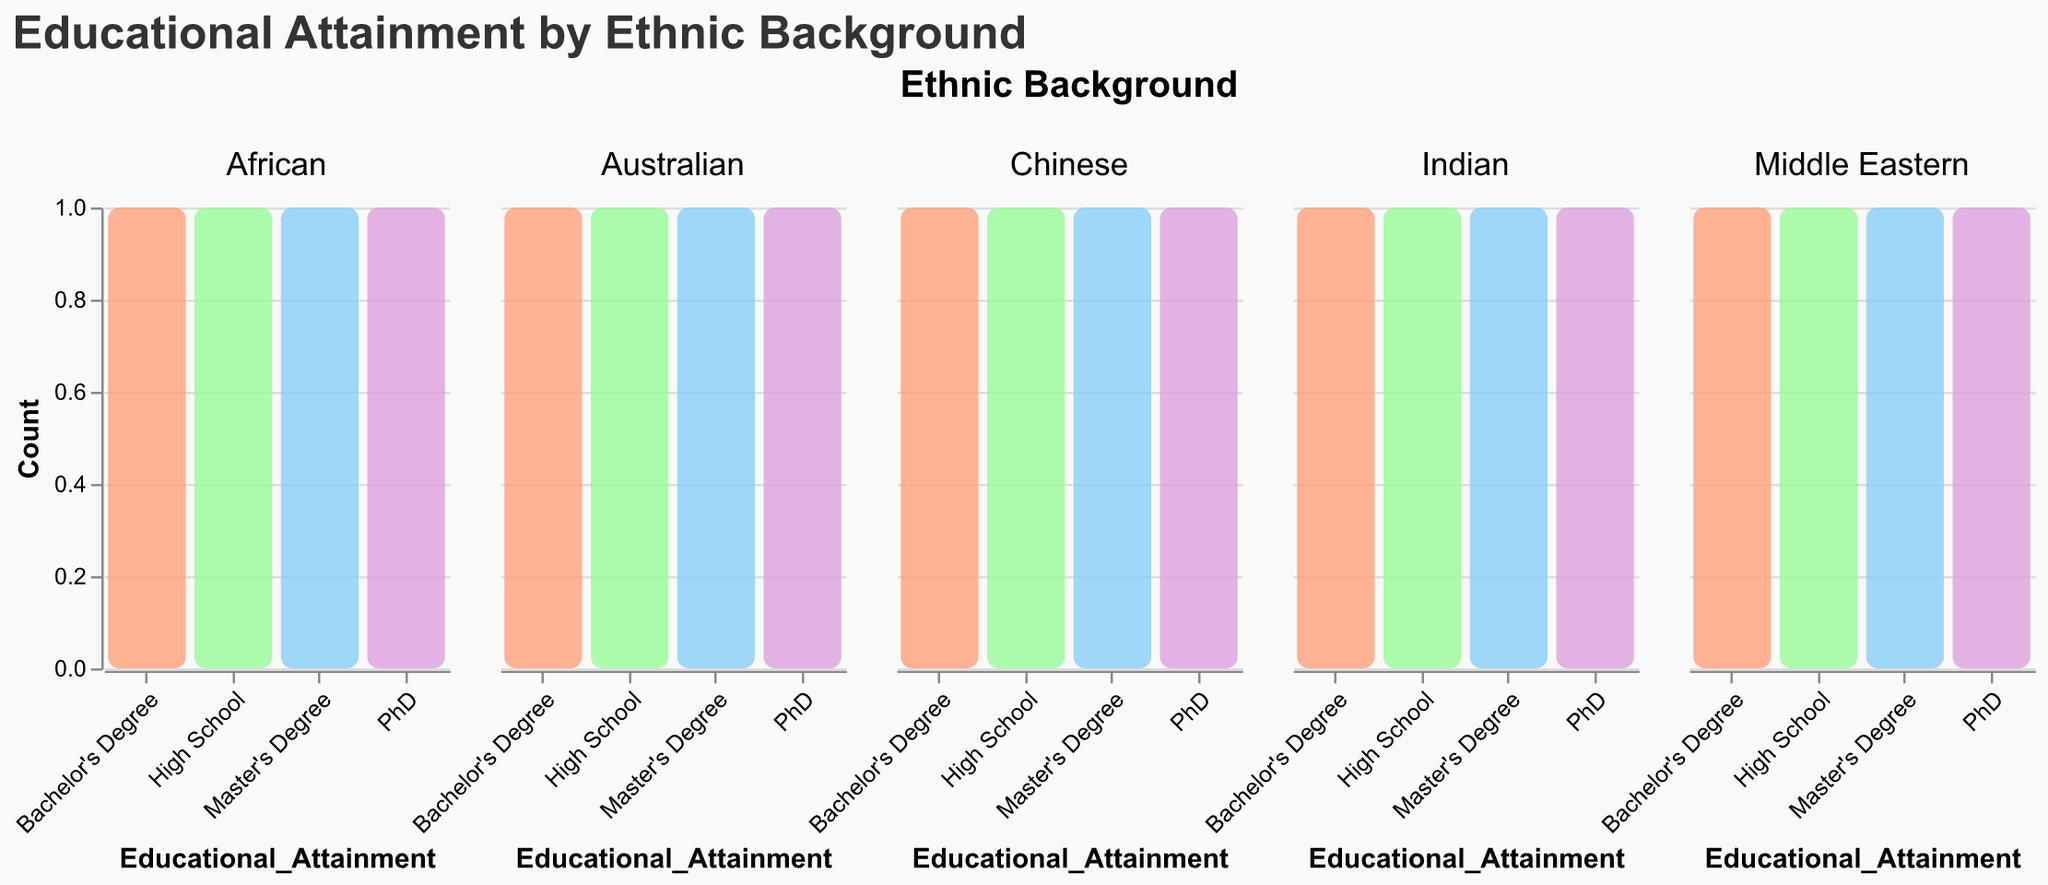What is the title of the figure? The title is usually at the top of the figure. It often gives a summary of what the figure is about. In this case, the title is "Educational Attainment by Ethnic Background" indicating the focus on educational levels across different ethnic groups in Australia.
Answer: Educational Attainment by Ethnic Background Which ethnic background has the highest count of Master's Degree holders? To answer this, look at the tallest bar representing the count of Master's Degree holders across the different facets (ethnic backgrounds). The facet with the tallest bar in the Master's Degree category indicates the highest count.
Answer: Australian How many different educational attainment levels are represented in this figure? Educational attainment levels are represented on the x-axis and by the colors used in the bars. From the figure, these levels are "High School," "Bachelor's Degree," "Master's Degree," and "PhD," making a total of four.
Answer: Four Compare the count of Bachelor's Degree holders between the Australian and Chinese ethnic backgrounds. Examine the height of the bars representing the Bachelor's Degree holders in the facets for Australian and Chinese ethnic backgrounds. Compare their heights directly from the bars.
Answer: They are equal Which educational attainment level has the most variation across different ethnic backgrounds? To determine this, observe which category has bars of varying heights in different facets. Note the diversity in bar heights across facets representing that category.
Answer: High School What is the difference in the count of PhD holders between the Indian and African ethnic backgrounds? Look at the height (count) of the bars representing PhD holders in both the Indian and African facets. Subtract the height of the bar in the African section from the height of the bar in the Indian section.
Answer: Zero Which ethnic background has the lowest count for High School attainment? Determine the ethnic background facet that has the shortest bar in the High School category. This indicates the lowest count.
Answer: Australian Summarize the educational attainment trend seen in the Middle Eastern ethnic background. Observe the heights of the bars in the Middle Eastern facet to understand how educational attainment levels vary. Note any patterns in the relative heights of bars from High School to PhD to summarize the general trend.
Answer: Increasing educational attainment How does the educational attainment for African students compare to Chinese students? Compare the relative heights of bars for each educational attainment category between the facets for African and Chinese ethnic backgrounds. Identify if one has consistently higher or varying trends in attainment levels.
Answer: Similar trends 